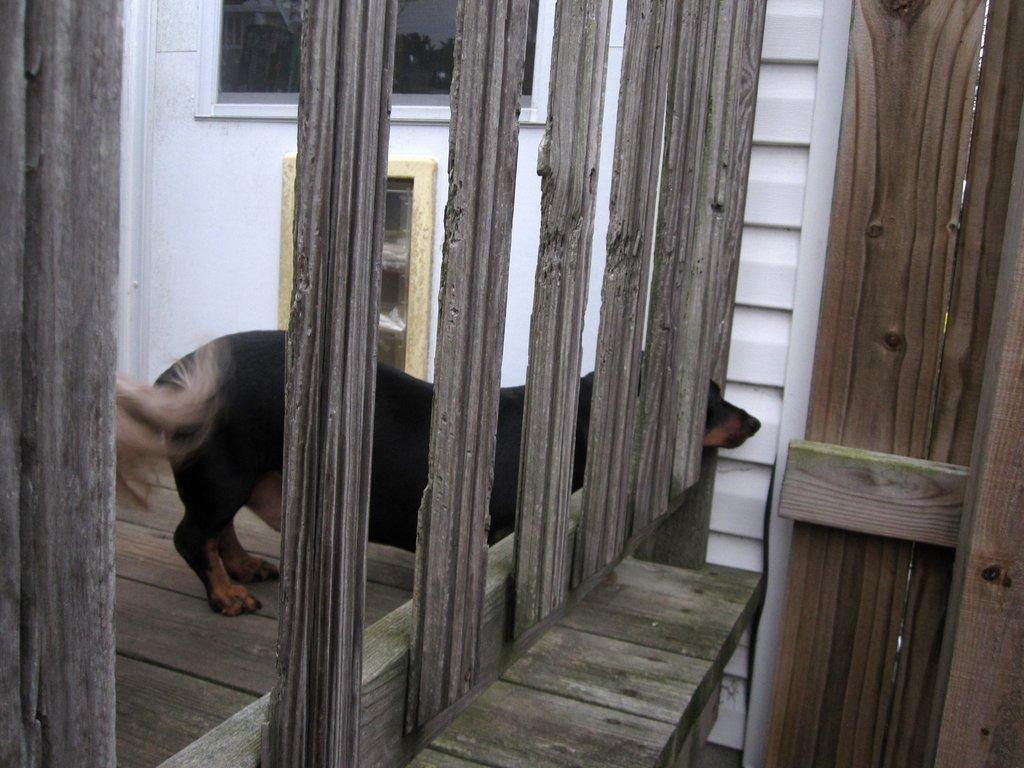What is the main structure in the foreground of the image? There is a wooden construction in the foreground of the image. What can be seen in the center of the image? There is a gate in the center of the image. What type of window is present at the top of the image? There is a glass window at the top of the image. What color is the wall surrounding the wooden construction and gate? The wall is painted white. What is the purpose of the chin in the image? There is no chin present in the image, as it is a photograph of a wooden construction, gate, and wall. How many hands are visible in the image? There are no hands visible in the image. 